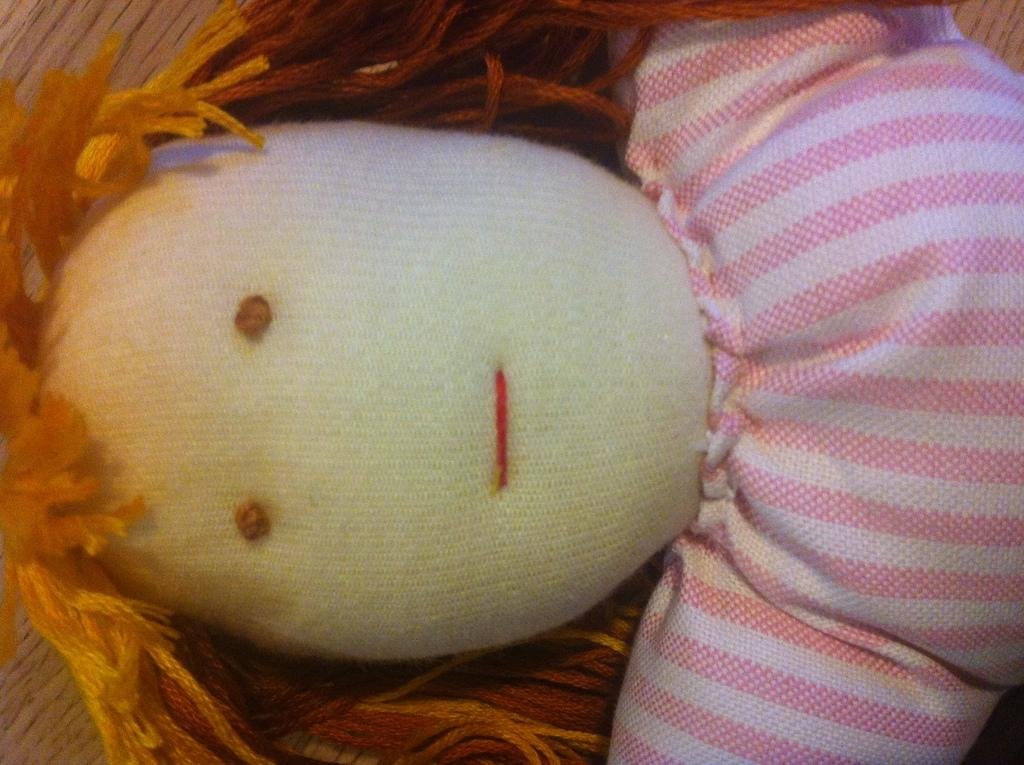What is the main subject in the center of the image? There is a doll in the center of the image. What type of bone can be seen in the doll's hand in the image? There is no bone present in the image; it features a doll without any additional objects. 